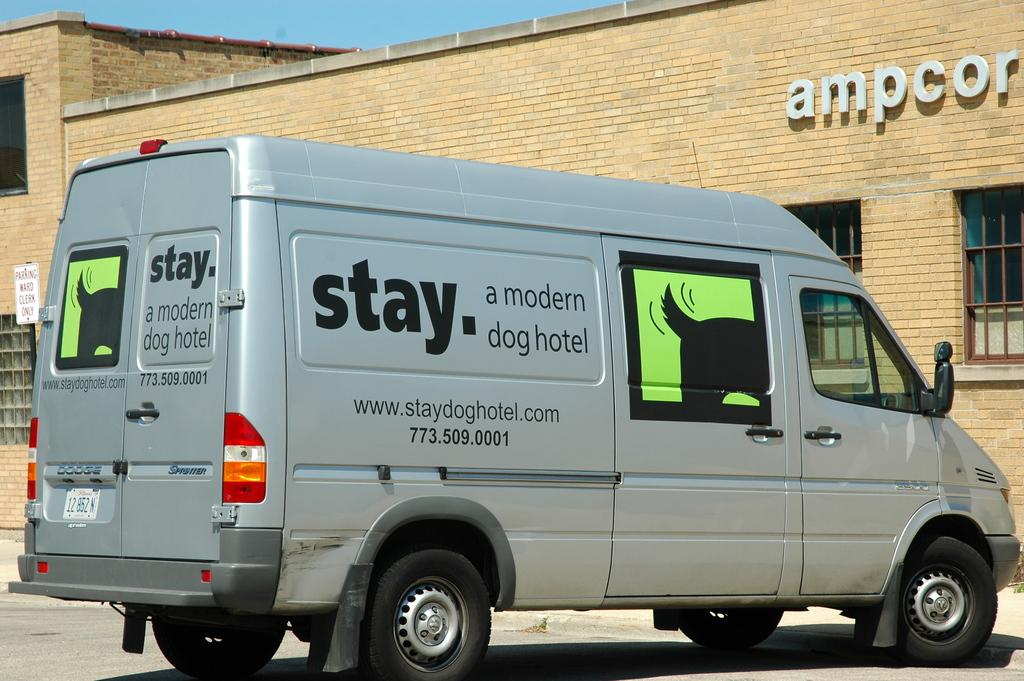What is the main subject of the image? There is a vehicle in the image. Can you describe the color of the vehicle? The vehicle is silver in color. What can be seen in the background of the image? There is a cream color building and the sky visible in the background of the image. Does the vehicle have a partner in the image? There is no indication of a partner for the vehicle in the image. How does the vehicle control the traffic in the image? The image does not show the vehicle controlling traffic; it only shows the vehicle itself. 